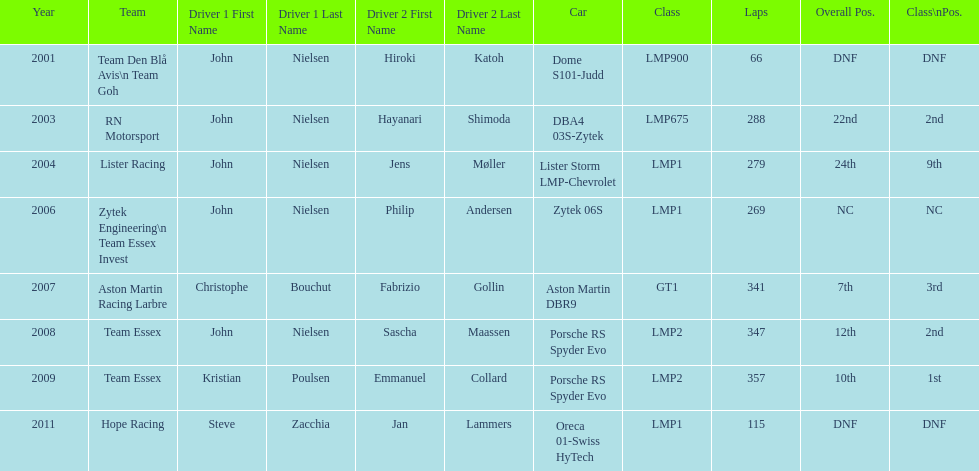How many times was the final position above 20? 2. 